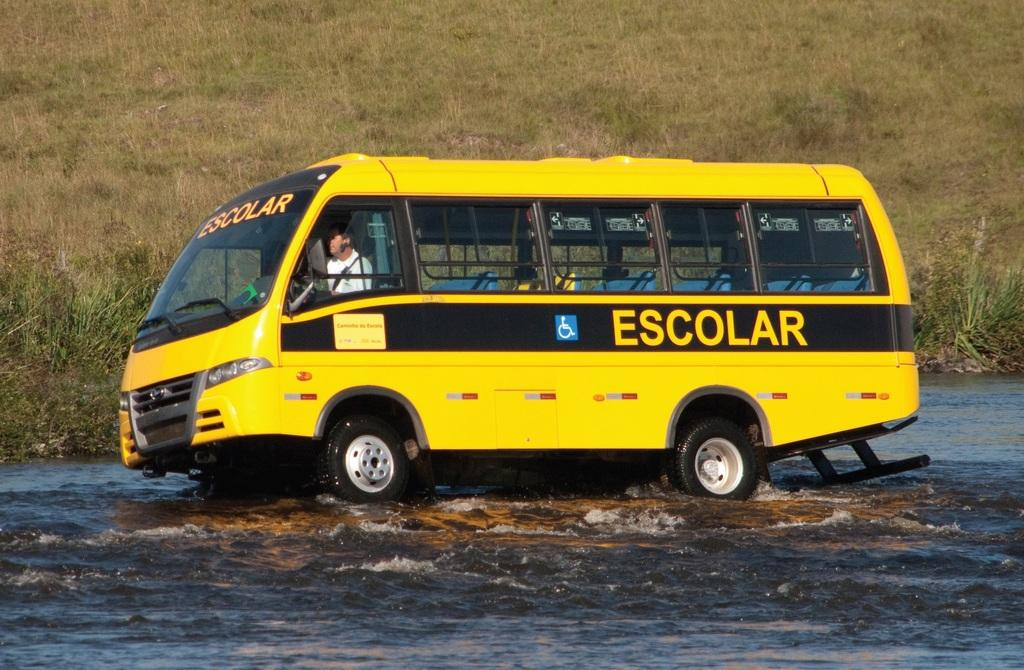<image>
Write a terse but informative summary of the picture. a yellow bus with ESCOLAR written on the side 